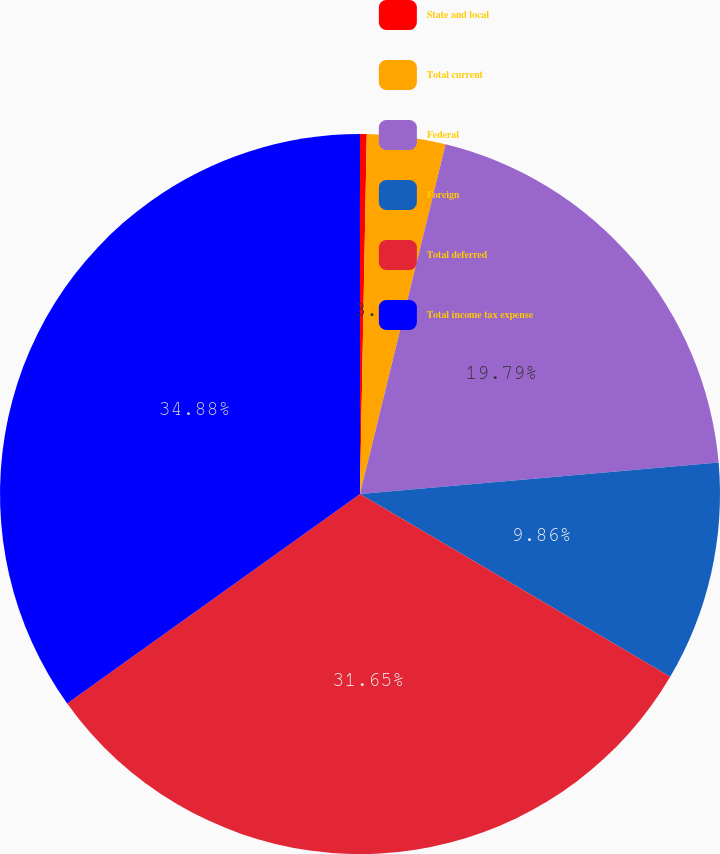Convert chart to OTSL. <chart><loc_0><loc_0><loc_500><loc_500><pie_chart><fcel>State and local<fcel>Total current<fcel>Federal<fcel>Foreign<fcel>Total deferred<fcel>Total income tax expense<nl><fcel>0.3%<fcel>3.52%<fcel>19.79%<fcel>9.86%<fcel>31.65%<fcel>34.88%<nl></chart> 